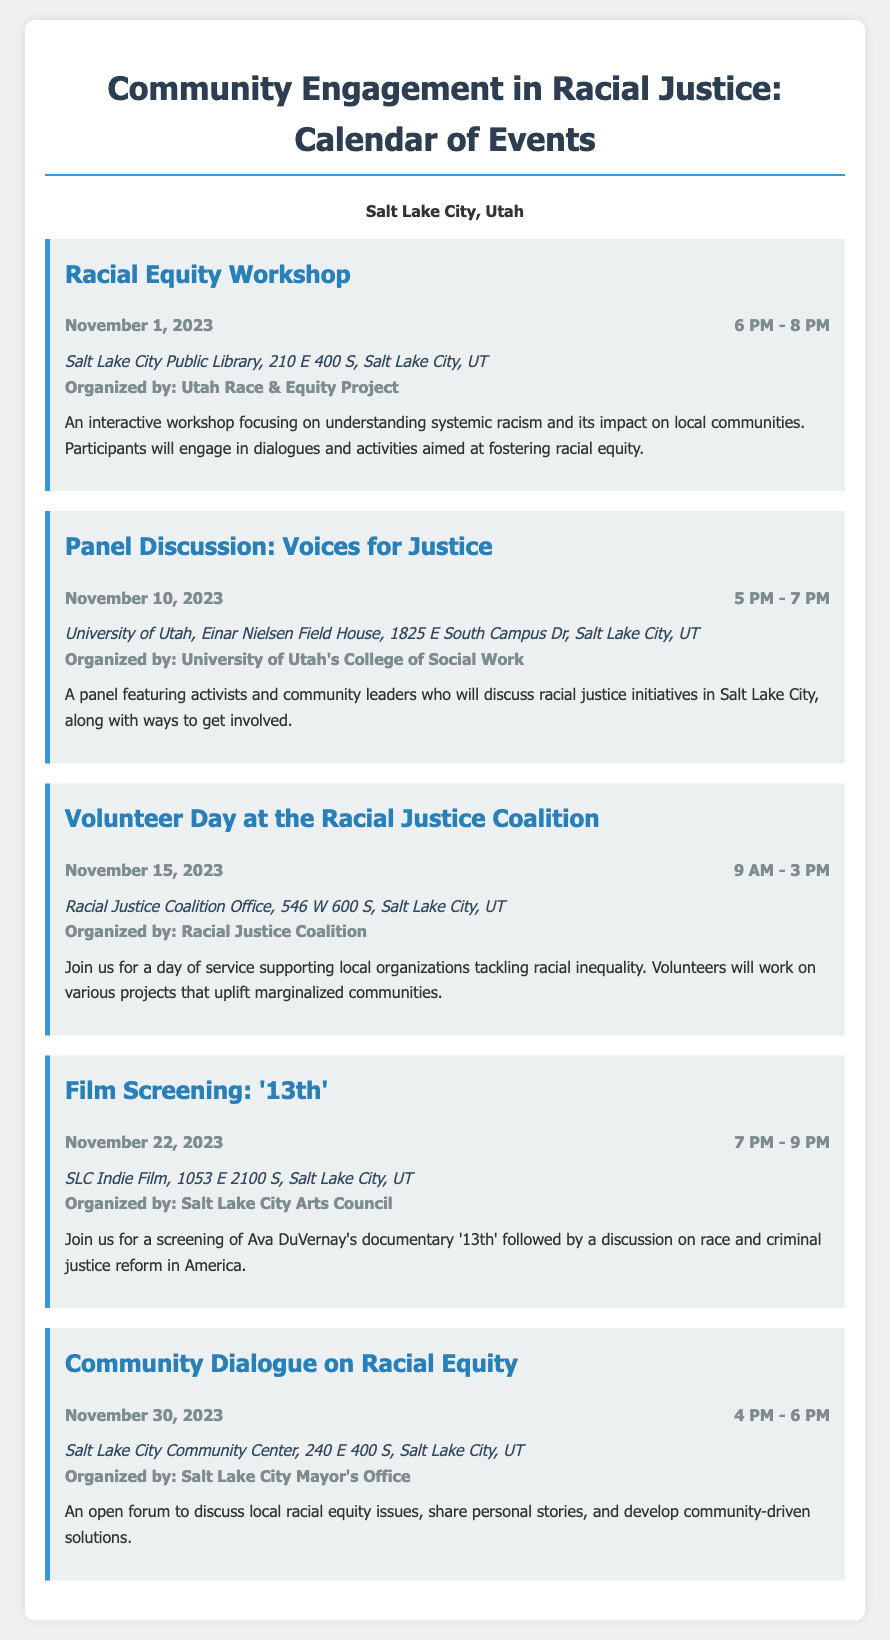What is the date of the Racial Equity Workshop? The event details state that the Racial Equity Workshop is scheduled for November 1, 2023.
Answer: November 1, 2023 Who is organizing the Panel Discussion: Voices for Justice? The organizer of the Panel Discussion is mentioned as the University of Utah's College of Social Work.
Answer: University of Utah's College of Social Work What is the time duration for the Volunteer Day at the Racial Justice Coalition? The event details specify that the Volunteer Day will take place from 9 AM to 3 PM, spanning six hours.
Answer: 9 AM - 3 PM Where will the film screening of '13th' be held? The location for the film screening is provided as SLC Indie Film, 1053 E 2100 S, Salt Lake City, UT.
Answer: SLC Indie Film, 1053 E 2100 S, Salt Lake City, UT What is the purpose of the Community Dialogue on Racial Equity? The document indicates that it is an open forum to discuss local racial equity issues and share personal stories.
Answer: Discuss local racial equity issues What is the main focus of the Racial Equity Workshop? The workshop's description outlines that it focuses on understanding systemic racism and its impact on local communities.
Answer: Understanding systemic racism How many events are scheduled in total for November 2023? By counting the events listed in the document, there are five events scheduled for November.
Answer: Five What type of activity is the Volunteer Day at the Racial Justice Coalition? The description states that the Volunteer Day involves a day of service supporting local organizations.
Answer: Day of service What follows the film screening of '13th'? The document mentions that there will be a discussion on race and criminal justice reform following the screening.
Answer: A discussion on race and criminal justice reform 